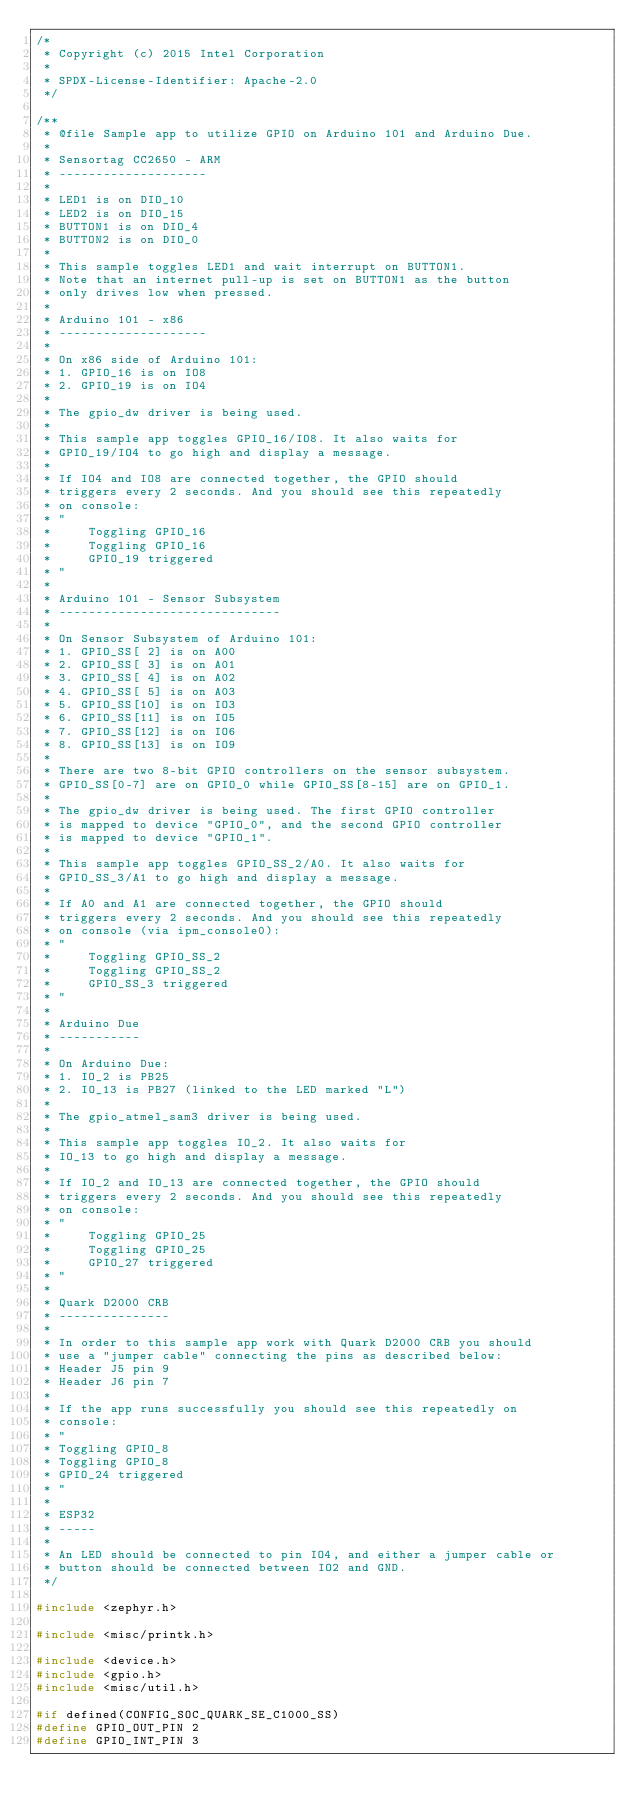<code> <loc_0><loc_0><loc_500><loc_500><_C_>/*
 * Copyright (c) 2015 Intel Corporation
 *
 * SPDX-License-Identifier: Apache-2.0
 */

/**
 * @file Sample app to utilize GPIO on Arduino 101 and Arduino Due.
 *
 * Sensortag CC2650 - ARM
 * --------------------
 *
 * LED1 is on DIO_10
 * LED2 is on DIO_15
 * BUTTON1 is on DIO_4
 * BUTTON2 is on DIO_0
 *
 * This sample toggles LED1 and wait interrupt on BUTTON1.
 * Note that an internet pull-up is set on BUTTON1 as the button
 * only drives low when pressed.
 *
 * Arduino 101 - x86
 * --------------------
 *
 * On x86 side of Arduino 101:
 * 1. GPIO_16 is on IO8
 * 2. GPIO_19 is on IO4
 *
 * The gpio_dw driver is being used.
 *
 * This sample app toggles GPIO_16/IO8. It also waits for
 * GPIO_19/IO4 to go high and display a message.
 *
 * If IO4 and IO8 are connected together, the GPIO should
 * triggers every 2 seconds. And you should see this repeatedly
 * on console:
 * "
 *     Toggling GPIO_16
 *     Toggling GPIO_16
 *     GPIO_19 triggered
 * "
 *
 * Arduino 101 - Sensor Subsystem
 * ------------------------------
 *
 * On Sensor Subsystem of Arduino 101:
 * 1. GPIO_SS[ 2] is on A00
 * 2. GPIO_SS[ 3] is on A01
 * 3. GPIO_SS[ 4] is on A02
 * 4. GPIO_SS[ 5] is on A03
 * 5. GPIO_SS[10] is on IO3
 * 6. GPIO_SS[11] is on IO5
 * 7. GPIO_SS[12] is on IO6
 * 8. GPIO_SS[13] is on IO9
 *
 * There are two 8-bit GPIO controllers on the sensor subsystem.
 * GPIO_SS[0-7] are on GPIO_0 while GPIO_SS[8-15] are on GPIO_1.
 *
 * The gpio_dw driver is being used. The first GPIO controller
 * is mapped to device "GPIO_0", and the second GPIO controller
 * is mapped to device "GPIO_1".
 *
 * This sample app toggles GPIO_SS_2/A0. It also waits for
 * GPIO_SS_3/A1 to go high and display a message.
 *
 * If A0 and A1 are connected together, the GPIO should
 * triggers every 2 seconds. And you should see this repeatedly
 * on console (via ipm_console0):
 * "
 *     Toggling GPIO_SS_2
 *     Toggling GPIO_SS_2
 *     GPIO_SS_3 triggered
 * "
 *
 * Arduino Due
 * -----------
 *
 * On Arduino Due:
 * 1. IO_2 is PB25
 * 2. IO_13 is PB27 (linked to the LED marked "L")
 *
 * The gpio_atmel_sam3 driver is being used.
 *
 * This sample app toggles IO_2. It also waits for
 * IO_13 to go high and display a message.
 *
 * If IO_2 and IO_13 are connected together, the GPIO should
 * triggers every 2 seconds. And you should see this repeatedly
 * on console:
 * "
 *     Toggling GPIO_25
 *     Toggling GPIO_25
 *     GPIO_27 triggered
 * "
 *
 * Quark D2000 CRB
 * ---------------
 *
 * In order to this sample app work with Quark D2000 CRB you should
 * use a "jumper cable" connecting the pins as described below:
 * Header J5 pin 9
 * Header J6 pin 7
 *
 * If the app runs successfully you should see this repeatedly on
 * console:
 * "
 * Toggling GPIO_8
 * Toggling GPIO_8
 * GPIO_24 triggered
 * "
 *
 * ESP32
 * -----
 *
 * An LED should be connected to pin IO4, and either a jumper cable or
 * button should be connected between IO2 and GND.
 */

#include <zephyr.h>

#include <misc/printk.h>

#include <device.h>
#include <gpio.h>
#include <misc/util.h>

#if defined(CONFIG_SOC_QUARK_SE_C1000_SS)
#define GPIO_OUT_PIN 2
#define GPIO_INT_PIN 3</code> 